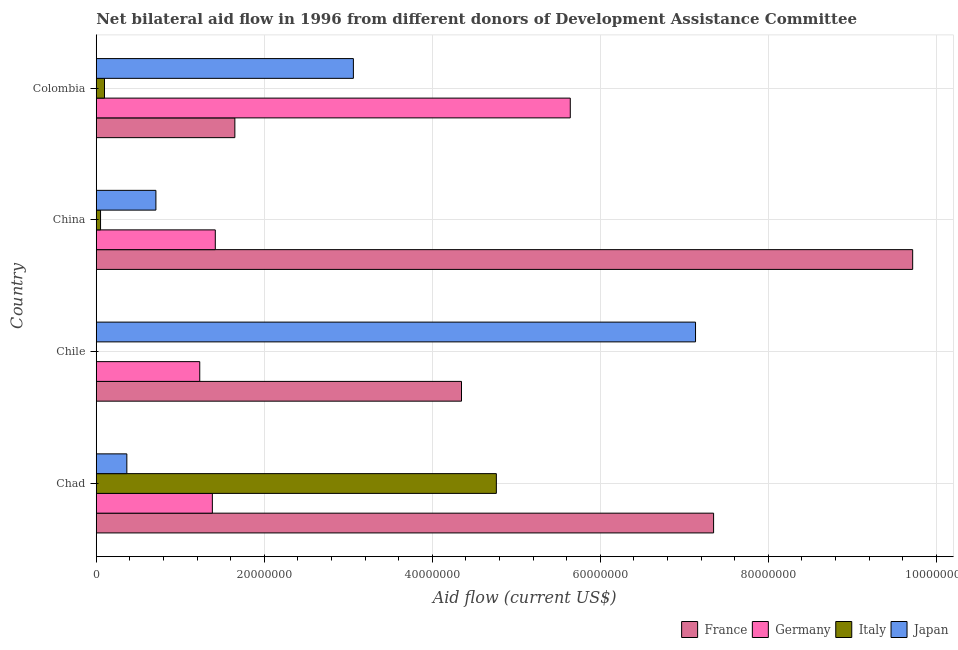How many different coloured bars are there?
Your answer should be very brief. 4. How many groups of bars are there?
Your response must be concise. 4. How many bars are there on the 2nd tick from the top?
Make the answer very short. 4. In how many cases, is the number of bars for a given country not equal to the number of legend labels?
Offer a terse response. 1. What is the amount of aid given by france in China?
Your answer should be very brief. 9.72e+07. Across all countries, what is the maximum amount of aid given by germany?
Provide a short and direct response. 5.64e+07. In which country was the amount of aid given by italy maximum?
Provide a succinct answer. Chad. What is the total amount of aid given by germany in the graph?
Your answer should be compact. 9.67e+07. What is the difference between the amount of aid given by france in Chile and that in Colombia?
Offer a very short reply. 2.70e+07. What is the difference between the amount of aid given by france in China and the amount of aid given by germany in Chile?
Your answer should be very brief. 8.49e+07. What is the average amount of aid given by france per country?
Make the answer very short. 5.77e+07. What is the difference between the amount of aid given by france and amount of aid given by italy in China?
Give a very brief answer. 9.67e+07. In how many countries, is the amount of aid given by france greater than 12000000 US$?
Provide a succinct answer. 4. What is the ratio of the amount of aid given by france in Chad to that in Colombia?
Keep it short and to the point. 4.45. Is the amount of aid given by france in Chile less than that in Colombia?
Offer a very short reply. No. Is the difference between the amount of aid given by italy in China and Colombia greater than the difference between the amount of aid given by france in China and Colombia?
Offer a terse response. No. What is the difference between the highest and the second highest amount of aid given by italy?
Your answer should be very brief. 4.66e+07. What is the difference between the highest and the lowest amount of aid given by germany?
Provide a short and direct response. 4.41e+07. In how many countries, is the amount of aid given by italy greater than the average amount of aid given by italy taken over all countries?
Give a very brief answer. 1. Is the sum of the amount of aid given by japan in Chile and Colombia greater than the maximum amount of aid given by germany across all countries?
Make the answer very short. Yes. Is it the case that in every country, the sum of the amount of aid given by france and amount of aid given by germany is greater than the amount of aid given by italy?
Make the answer very short. Yes. How many bars are there?
Make the answer very short. 15. Are all the bars in the graph horizontal?
Provide a short and direct response. Yes. How many countries are there in the graph?
Your response must be concise. 4. What is the difference between two consecutive major ticks on the X-axis?
Your response must be concise. 2.00e+07. Where does the legend appear in the graph?
Offer a terse response. Bottom right. How are the legend labels stacked?
Offer a very short reply. Horizontal. What is the title of the graph?
Your answer should be very brief. Net bilateral aid flow in 1996 from different donors of Development Assistance Committee. What is the label or title of the X-axis?
Provide a succinct answer. Aid flow (current US$). What is the label or title of the Y-axis?
Ensure brevity in your answer.  Country. What is the Aid flow (current US$) of France in Chad?
Your response must be concise. 7.35e+07. What is the Aid flow (current US$) of Germany in Chad?
Your response must be concise. 1.38e+07. What is the Aid flow (current US$) in Italy in Chad?
Your response must be concise. 4.76e+07. What is the Aid flow (current US$) of Japan in Chad?
Give a very brief answer. 3.64e+06. What is the Aid flow (current US$) in France in Chile?
Keep it short and to the point. 4.35e+07. What is the Aid flow (current US$) of Germany in Chile?
Offer a very short reply. 1.23e+07. What is the Aid flow (current US$) in Japan in Chile?
Provide a succinct answer. 7.13e+07. What is the Aid flow (current US$) in France in China?
Provide a short and direct response. 9.72e+07. What is the Aid flow (current US$) in Germany in China?
Offer a very short reply. 1.42e+07. What is the Aid flow (current US$) in Italy in China?
Give a very brief answer. 5.10e+05. What is the Aid flow (current US$) of Japan in China?
Your answer should be compact. 7.10e+06. What is the Aid flow (current US$) of France in Colombia?
Give a very brief answer. 1.65e+07. What is the Aid flow (current US$) in Germany in Colombia?
Keep it short and to the point. 5.64e+07. What is the Aid flow (current US$) in Italy in Colombia?
Your response must be concise. 9.80e+05. What is the Aid flow (current US$) in Japan in Colombia?
Offer a terse response. 3.06e+07. Across all countries, what is the maximum Aid flow (current US$) of France?
Your response must be concise. 9.72e+07. Across all countries, what is the maximum Aid flow (current US$) of Germany?
Your answer should be compact. 5.64e+07. Across all countries, what is the maximum Aid flow (current US$) in Italy?
Offer a very short reply. 4.76e+07. Across all countries, what is the maximum Aid flow (current US$) of Japan?
Make the answer very short. 7.13e+07. Across all countries, what is the minimum Aid flow (current US$) in France?
Your response must be concise. 1.65e+07. Across all countries, what is the minimum Aid flow (current US$) in Germany?
Provide a short and direct response. 1.23e+07. Across all countries, what is the minimum Aid flow (current US$) of Italy?
Ensure brevity in your answer.  0. Across all countries, what is the minimum Aid flow (current US$) in Japan?
Make the answer very short. 3.64e+06. What is the total Aid flow (current US$) of France in the graph?
Your answer should be compact. 2.31e+08. What is the total Aid flow (current US$) in Germany in the graph?
Your response must be concise. 9.67e+07. What is the total Aid flow (current US$) of Italy in the graph?
Your response must be concise. 4.91e+07. What is the total Aid flow (current US$) in Japan in the graph?
Make the answer very short. 1.13e+08. What is the difference between the Aid flow (current US$) of France in Chad and that in Chile?
Your answer should be compact. 3.00e+07. What is the difference between the Aid flow (current US$) in Germany in Chad and that in Chile?
Your response must be concise. 1.50e+06. What is the difference between the Aid flow (current US$) of Japan in Chad and that in Chile?
Your answer should be very brief. -6.77e+07. What is the difference between the Aid flow (current US$) of France in Chad and that in China?
Offer a very short reply. -2.37e+07. What is the difference between the Aid flow (current US$) in Germany in Chad and that in China?
Provide a short and direct response. -3.50e+05. What is the difference between the Aid flow (current US$) in Italy in Chad and that in China?
Provide a succinct answer. 4.71e+07. What is the difference between the Aid flow (current US$) in Japan in Chad and that in China?
Ensure brevity in your answer.  -3.46e+06. What is the difference between the Aid flow (current US$) in France in Chad and that in Colombia?
Your answer should be very brief. 5.70e+07. What is the difference between the Aid flow (current US$) in Germany in Chad and that in Colombia?
Ensure brevity in your answer.  -4.26e+07. What is the difference between the Aid flow (current US$) of Italy in Chad and that in Colombia?
Provide a succinct answer. 4.66e+07. What is the difference between the Aid flow (current US$) in Japan in Chad and that in Colombia?
Your answer should be very brief. -2.70e+07. What is the difference between the Aid flow (current US$) of France in Chile and that in China?
Your response must be concise. -5.37e+07. What is the difference between the Aid flow (current US$) in Germany in Chile and that in China?
Your answer should be compact. -1.85e+06. What is the difference between the Aid flow (current US$) in Japan in Chile and that in China?
Your response must be concise. 6.42e+07. What is the difference between the Aid flow (current US$) of France in Chile and that in Colombia?
Provide a succinct answer. 2.70e+07. What is the difference between the Aid flow (current US$) in Germany in Chile and that in Colombia?
Your answer should be compact. -4.41e+07. What is the difference between the Aid flow (current US$) in Japan in Chile and that in Colombia?
Make the answer very short. 4.07e+07. What is the difference between the Aid flow (current US$) of France in China and that in Colombia?
Your answer should be very brief. 8.07e+07. What is the difference between the Aid flow (current US$) in Germany in China and that in Colombia?
Offer a terse response. -4.23e+07. What is the difference between the Aid flow (current US$) of Italy in China and that in Colombia?
Your answer should be very brief. -4.70e+05. What is the difference between the Aid flow (current US$) of Japan in China and that in Colombia?
Provide a succinct answer. -2.35e+07. What is the difference between the Aid flow (current US$) in France in Chad and the Aid flow (current US$) in Germany in Chile?
Offer a very short reply. 6.12e+07. What is the difference between the Aid flow (current US$) in France in Chad and the Aid flow (current US$) in Japan in Chile?
Your answer should be compact. 2.15e+06. What is the difference between the Aid flow (current US$) in Germany in Chad and the Aid flow (current US$) in Japan in Chile?
Make the answer very short. -5.75e+07. What is the difference between the Aid flow (current US$) in Italy in Chad and the Aid flow (current US$) in Japan in Chile?
Provide a short and direct response. -2.37e+07. What is the difference between the Aid flow (current US$) of France in Chad and the Aid flow (current US$) of Germany in China?
Make the answer very short. 5.93e+07. What is the difference between the Aid flow (current US$) of France in Chad and the Aid flow (current US$) of Italy in China?
Offer a terse response. 7.30e+07. What is the difference between the Aid flow (current US$) in France in Chad and the Aid flow (current US$) in Japan in China?
Make the answer very short. 6.64e+07. What is the difference between the Aid flow (current US$) in Germany in Chad and the Aid flow (current US$) in Italy in China?
Make the answer very short. 1.33e+07. What is the difference between the Aid flow (current US$) in Germany in Chad and the Aid flow (current US$) in Japan in China?
Keep it short and to the point. 6.72e+06. What is the difference between the Aid flow (current US$) in Italy in Chad and the Aid flow (current US$) in Japan in China?
Provide a short and direct response. 4.05e+07. What is the difference between the Aid flow (current US$) of France in Chad and the Aid flow (current US$) of Germany in Colombia?
Ensure brevity in your answer.  1.71e+07. What is the difference between the Aid flow (current US$) in France in Chad and the Aid flow (current US$) in Italy in Colombia?
Provide a short and direct response. 7.25e+07. What is the difference between the Aid flow (current US$) of France in Chad and the Aid flow (current US$) of Japan in Colombia?
Your answer should be very brief. 4.29e+07. What is the difference between the Aid flow (current US$) in Germany in Chad and the Aid flow (current US$) in Italy in Colombia?
Give a very brief answer. 1.28e+07. What is the difference between the Aid flow (current US$) of Germany in Chad and the Aid flow (current US$) of Japan in Colombia?
Make the answer very short. -1.68e+07. What is the difference between the Aid flow (current US$) in Italy in Chad and the Aid flow (current US$) in Japan in Colombia?
Make the answer very short. 1.70e+07. What is the difference between the Aid flow (current US$) of France in Chile and the Aid flow (current US$) of Germany in China?
Your answer should be compact. 2.93e+07. What is the difference between the Aid flow (current US$) in France in Chile and the Aid flow (current US$) in Italy in China?
Offer a very short reply. 4.30e+07. What is the difference between the Aid flow (current US$) of France in Chile and the Aid flow (current US$) of Japan in China?
Offer a very short reply. 3.64e+07. What is the difference between the Aid flow (current US$) in Germany in Chile and the Aid flow (current US$) in Italy in China?
Offer a very short reply. 1.18e+07. What is the difference between the Aid flow (current US$) in Germany in Chile and the Aid flow (current US$) in Japan in China?
Your response must be concise. 5.22e+06. What is the difference between the Aid flow (current US$) of France in Chile and the Aid flow (current US$) of Germany in Colombia?
Offer a very short reply. -1.30e+07. What is the difference between the Aid flow (current US$) of France in Chile and the Aid flow (current US$) of Italy in Colombia?
Offer a very short reply. 4.25e+07. What is the difference between the Aid flow (current US$) of France in Chile and the Aid flow (current US$) of Japan in Colombia?
Provide a short and direct response. 1.29e+07. What is the difference between the Aid flow (current US$) in Germany in Chile and the Aid flow (current US$) in Italy in Colombia?
Provide a short and direct response. 1.13e+07. What is the difference between the Aid flow (current US$) in Germany in Chile and the Aid flow (current US$) in Japan in Colombia?
Offer a very short reply. -1.83e+07. What is the difference between the Aid flow (current US$) of France in China and the Aid flow (current US$) of Germany in Colombia?
Your answer should be compact. 4.08e+07. What is the difference between the Aid flow (current US$) of France in China and the Aid flow (current US$) of Italy in Colombia?
Your response must be concise. 9.62e+07. What is the difference between the Aid flow (current US$) in France in China and the Aid flow (current US$) in Japan in Colombia?
Provide a succinct answer. 6.66e+07. What is the difference between the Aid flow (current US$) in Germany in China and the Aid flow (current US$) in Italy in Colombia?
Your response must be concise. 1.32e+07. What is the difference between the Aid flow (current US$) in Germany in China and the Aid flow (current US$) in Japan in Colombia?
Make the answer very short. -1.64e+07. What is the difference between the Aid flow (current US$) of Italy in China and the Aid flow (current US$) of Japan in Colombia?
Provide a succinct answer. -3.01e+07. What is the average Aid flow (current US$) in France per country?
Provide a short and direct response. 5.77e+07. What is the average Aid flow (current US$) of Germany per country?
Keep it short and to the point. 2.42e+07. What is the average Aid flow (current US$) of Italy per country?
Offer a very short reply. 1.23e+07. What is the average Aid flow (current US$) in Japan per country?
Keep it short and to the point. 2.82e+07. What is the difference between the Aid flow (current US$) in France and Aid flow (current US$) in Germany in Chad?
Your response must be concise. 5.97e+07. What is the difference between the Aid flow (current US$) of France and Aid flow (current US$) of Italy in Chad?
Your answer should be very brief. 2.59e+07. What is the difference between the Aid flow (current US$) of France and Aid flow (current US$) of Japan in Chad?
Provide a succinct answer. 6.98e+07. What is the difference between the Aid flow (current US$) in Germany and Aid flow (current US$) in Italy in Chad?
Offer a very short reply. -3.38e+07. What is the difference between the Aid flow (current US$) in Germany and Aid flow (current US$) in Japan in Chad?
Provide a succinct answer. 1.02e+07. What is the difference between the Aid flow (current US$) in Italy and Aid flow (current US$) in Japan in Chad?
Your response must be concise. 4.40e+07. What is the difference between the Aid flow (current US$) of France and Aid flow (current US$) of Germany in Chile?
Offer a very short reply. 3.12e+07. What is the difference between the Aid flow (current US$) in France and Aid flow (current US$) in Japan in Chile?
Ensure brevity in your answer.  -2.79e+07. What is the difference between the Aid flow (current US$) in Germany and Aid flow (current US$) in Japan in Chile?
Offer a terse response. -5.90e+07. What is the difference between the Aid flow (current US$) of France and Aid flow (current US$) of Germany in China?
Make the answer very short. 8.30e+07. What is the difference between the Aid flow (current US$) of France and Aid flow (current US$) of Italy in China?
Provide a succinct answer. 9.67e+07. What is the difference between the Aid flow (current US$) of France and Aid flow (current US$) of Japan in China?
Give a very brief answer. 9.01e+07. What is the difference between the Aid flow (current US$) of Germany and Aid flow (current US$) of Italy in China?
Your answer should be very brief. 1.37e+07. What is the difference between the Aid flow (current US$) of Germany and Aid flow (current US$) of Japan in China?
Your answer should be compact. 7.07e+06. What is the difference between the Aid flow (current US$) of Italy and Aid flow (current US$) of Japan in China?
Offer a terse response. -6.59e+06. What is the difference between the Aid flow (current US$) of France and Aid flow (current US$) of Germany in Colombia?
Provide a short and direct response. -3.99e+07. What is the difference between the Aid flow (current US$) of France and Aid flow (current US$) of Italy in Colombia?
Ensure brevity in your answer.  1.55e+07. What is the difference between the Aid flow (current US$) of France and Aid flow (current US$) of Japan in Colombia?
Ensure brevity in your answer.  -1.41e+07. What is the difference between the Aid flow (current US$) in Germany and Aid flow (current US$) in Italy in Colombia?
Give a very brief answer. 5.54e+07. What is the difference between the Aid flow (current US$) in Germany and Aid flow (current US$) in Japan in Colombia?
Offer a terse response. 2.58e+07. What is the difference between the Aid flow (current US$) of Italy and Aid flow (current US$) of Japan in Colombia?
Keep it short and to the point. -2.96e+07. What is the ratio of the Aid flow (current US$) in France in Chad to that in Chile?
Provide a short and direct response. 1.69. What is the ratio of the Aid flow (current US$) of Germany in Chad to that in Chile?
Your response must be concise. 1.12. What is the ratio of the Aid flow (current US$) in Japan in Chad to that in Chile?
Offer a very short reply. 0.05. What is the ratio of the Aid flow (current US$) in France in Chad to that in China?
Offer a terse response. 0.76. What is the ratio of the Aid flow (current US$) in Germany in Chad to that in China?
Make the answer very short. 0.98. What is the ratio of the Aid flow (current US$) of Italy in Chad to that in China?
Provide a short and direct response. 93.39. What is the ratio of the Aid flow (current US$) of Japan in Chad to that in China?
Keep it short and to the point. 0.51. What is the ratio of the Aid flow (current US$) in France in Chad to that in Colombia?
Your answer should be very brief. 4.45. What is the ratio of the Aid flow (current US$) in Germany in Chad to that in Colombia?
Provide a short and direct response. 0.24. What is the ratio of the Aid flow (current US$) in Italy in Chad to that in Colombia?
Keep it short and to the point. 48.6. What is the ratio of the Aid flow (current US$) in Japan in Chad to that in Colombia?
Make the answer very short. 0.12. What is the ratio of the Aid flow (current US$) of France in Chile to that in China?
Make the answer very short. 0.45. What is the ratio of the Aid flow (current US$) of Germany in Chile to that in China?
Your answer should be compact. 0.87. What is the ratio of the Aid flow (current US$) of Japan in Chile to that in China?
Give a very brief answer. 10.05. What is the ratio of the Aid flow (current US$) of France in Chile to that in Colombia?
Make the answer very short. 2.64. What is the ratio of the Aid flow (current US$) in Germany in Chile to that in Colombia?
Keep it short and to the point. 0.22. What is the ratio of the Aid flow (current US$) of Japan in Chile to that in Colombia?
Provide a succinct answer. 2.33. What is the ratio of the Aid flow (current US$) of France in China to that in Colombia?
Keep it short and to the point. 5.89. What is the ratio of the Aid flow (current US$) in Germany in China to that in Colombia?
Keep it short and to the point. 0.25. What is the ratio of the Aid flow (current US$) in Italy in China to that in Colombia?
Provide a succinct answer. 0.52. What is the ratio of the Aid flow (current US$) of Japan in China to that in Colombia?
Your response must be concise. 0.23. What is the difference between the highest and the second highest Aid flow (current US$) in France?
Provide a short and direct response. 2.37e+07. What is the difference between the highest and the second highest Aid flow (current US$) of Germany?
Offer a terse response. 4.23e+07. What is the difference between the highest and the second highest Aid flow (current US$) of Italy?
Your response must be concise. 4.66e+07. What is the difference between the highest and the second highest Aid flow (current US$) of Japan?
Offer a terse response. 4.07e+07. What is the difference between the highest and the lowest Aid flow (current US$) of France?
Your answer should be compact. 8.07e+07. What is the difference between the highest and the lowest Aid flow (current US$) of Germany?
Provide a succinct answer. 4.41e+07. What is the difference between the highest and the lowest Aid flow (current US$) in Italy?
Provide a short and direct response. 4.76e+07. What is the difference between the highest and the lowest Aid flow (current US$) of Japan?
Ensure brevity in your answer.  6.77e+07. 